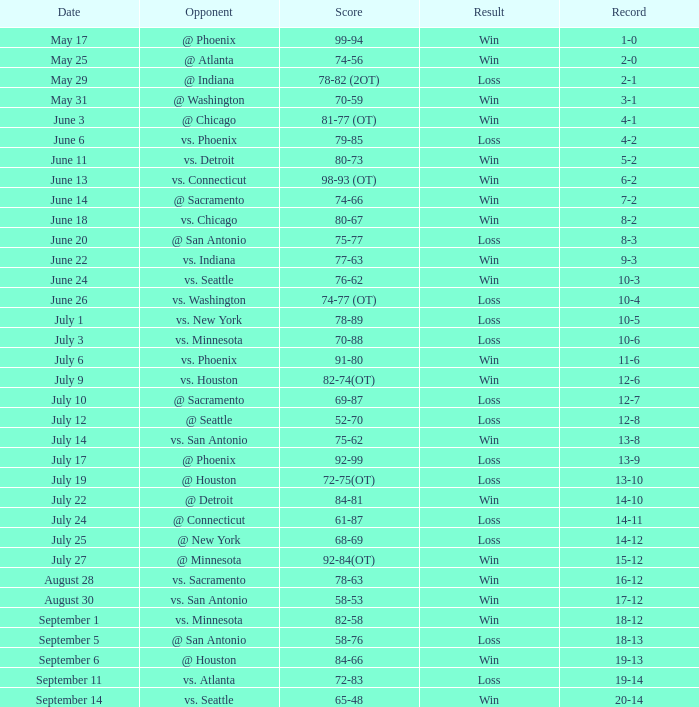What is the Score of the game @ San Antonio on June 20? 75-77. 